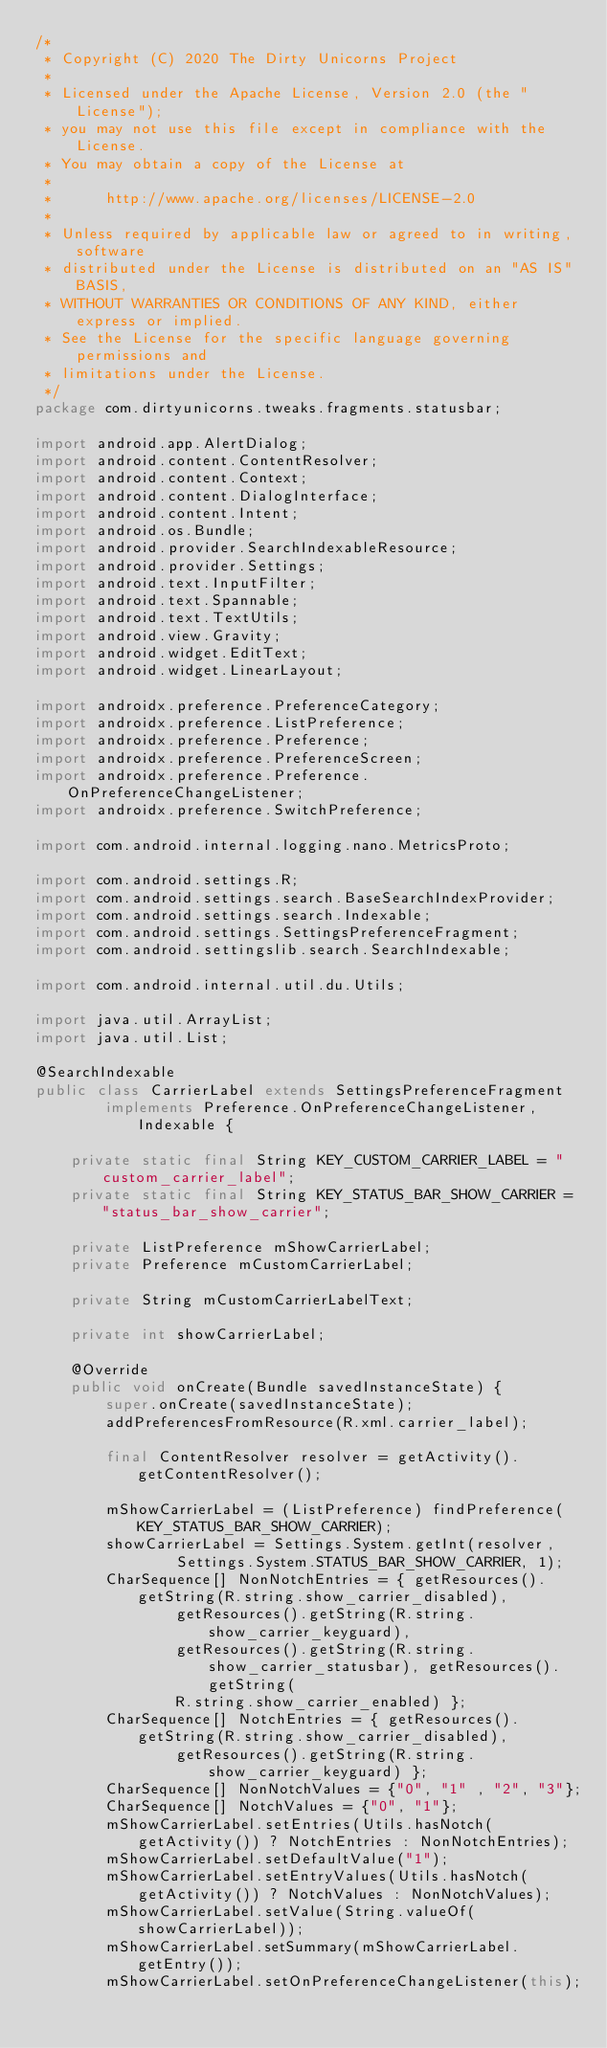Convert code to text. <code><loc_0><loc_0><loc_500><loc_500><_Java_>/*
 * Copyright (C) 2020 The Dirty Unicorns Project
 *
 * Licensed under the Apache License, Version 2.0 (the "License");
 * you may not use this file except in compliance with the License.
 * You may obtain a copy of the License at
 *
 *      http://www.apache.org/licenses/LICENSE-2.0
 *
 * Unless required by applicable law or agreed to in writing, software
 * distributed under the License is distributed on an "AS IS" BASIS,
 * WITHOUT WARRANTIES OR CONDITIONS OF ANY KIND, either express or implied.
 * See the License for the specific language governing permissions and
 * limitations under the License.
 */
package com.dirtyunicorns.tweaks.fragments.statusbar;

import android.app.AlertDialog;
import android.content.ContentResolver;
import android.content.Context;
import android.content.DialogInterface;
import android.content.Intent;
import android.os.Bundle;
import android.provider.SearchIndexableResource;
import android.provider.Settings;
import android.text.InputFilter;
import android.text.Spannable;
import android.text.TextUtils;
import android.view.Gravity;
import android.widget.EditText;
import android.widget.LinearLayout;

import androidx.preference.PreferenceCategory;
import androidx.preference.ListPreference;
import androidx.preference.Preference;
import androidx.preference.PreferenceScreen;
import androidx.preference.Preference.OnPreferenceChangeListener;
import androidx.preference.SwitchPreference;

import com.android.internal.logging.nano.MetricsProto;

import com.android.settings.R;
import com.android.settings.search.BaseSearchIndexProvider;
import com.android.settings.search.Indexable;
import com.android.settings.SettingsPreferenceFragment;
import com.android.settingslib.search.SearchIndexable;

import com.android.internal.util.du.Utils;

import java.util.ArrayList;
import java.util.List;

@SearchIndexable
public class CarrierLabel extends SettingsPreferenceFragment
        implements Preference.OnPreferenceChangeListener, Indexable {

    private static final String KEY_CUSTOM_CARRIER_LABEL = "custom_carrier_label";
    private static final String KEY_STATUS_BAR_SHOW_CARRIER = "status_bar_show_carrier";

    private ListPreference mShowCarrierLabel;
    private Preference mCustomCarrierLabel;

    private String mCustomCarrierLabelText;

    private int showCarrierLabel;

    @Override
    public void onCreate(Bundle savedInstanceState) {
        super.onCreate(savedInstanceState);
        addPreferencesFromResource(R.xml.carrier_label);

        final ContentResolver resolver = getActivity().getContentResolver();

        mShowCarrierLabel = (ListPreference) findPreference(KEY_STATUS_BAR_SHOW_CARRIER);
        showCarrierLabel = Settings.System.getInt(resolver,
                Settings.System.STATUS_BAR_SHOW_CARRIER, 1);
        CharSequence[] NonNotchEntries = { getResources().getString(R.string.show_carrier_disabled),
                getResources().getString(R.string.show_carrier_keyguard),
                getResources().getString(R.string.show_carrier_statusbar), getResources().getString(
                R.string.show_carrier_enabled) };
        CharSequence[] NotchEntries = { getResources().getString(R.string.show_carrier_disabled),
                getResources().getString(R.string.show_carrier_keyguard) };
        CharSequence[] NonNotchValues = {"0", "1" , "2", "3"};
        CharSequence[] NotchValues = {"0", "1"};
        mShowCarrierLabel.setEntries(Utils.hasNotch(getActivity()) ? NotchEntries : NonNotchEntries);
        mShowCarrierLabel.setDefaultValue("1");
        mShowCarrierLabel.setEntryValues(Utils.hasNotch(getActivity()) ? NotchValues : NonNotchValues);
        mShowCarrierLabel.setValue(String.valueOf(showCarrierLabel));
        mShowCarrierLabel.setSummary(mShowCarrierLabel.getEntry());
        mShowCarrierLabel.setOnPreferenceChangeListener(this);
</code> 